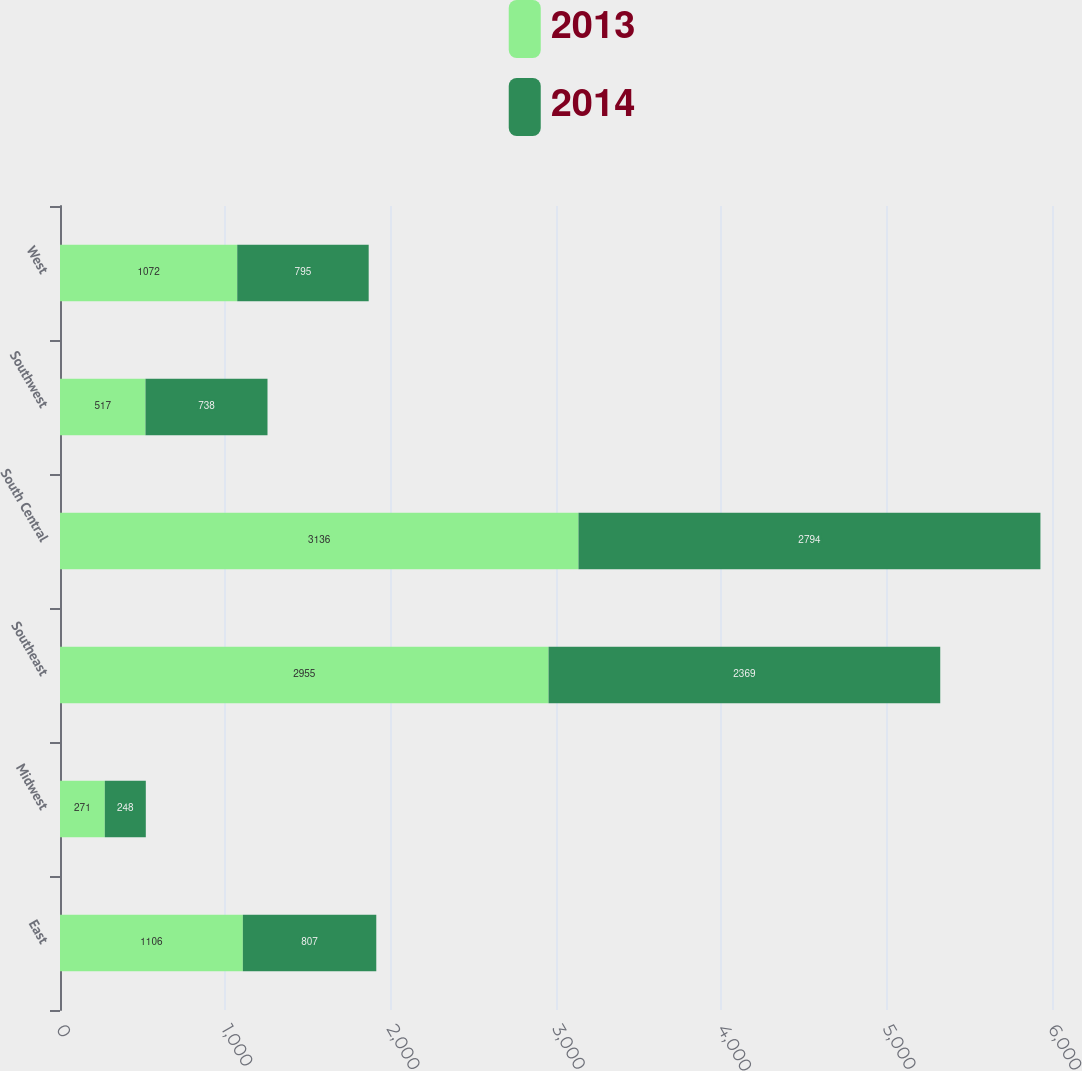Convert chart to OTSL. <chart><loc_0><loc_0><loc_500><loc_500><stacked_bar_chart><ecel><fcel>East<fcel>Midwest<fcel>Southeast<fcel>South Central<fcel>Southwest<fcel>West<nl><fcel>2013<fcel>1106<fcel>271<fcel>2955<fcel>3136<fcel>517<fcel>1072<nl><fcel>2014<fcel>807<fcel>248<fcel>2369<fcel>2794<fcel>738<fcel>795<nl></chart> 